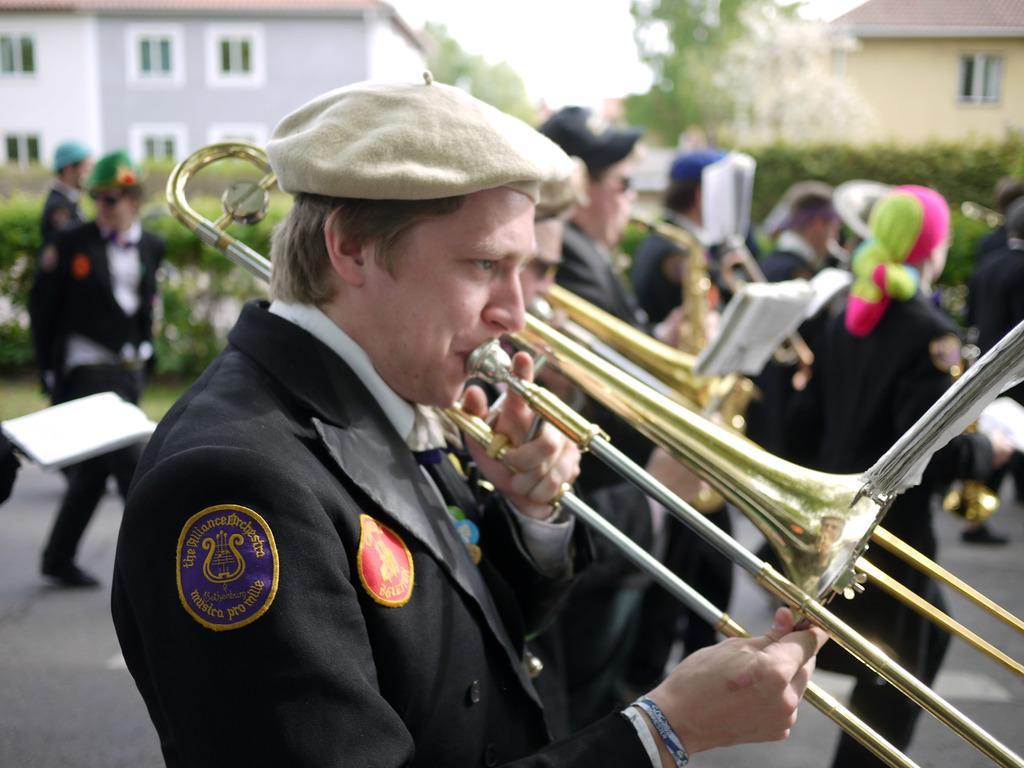Describe this image in one or two sentences. In this image, we can see persons wearing clothes. There are some persons playing musical instruments. In the background, image is blurred. There is a building in the top left and in the top right of the image. 